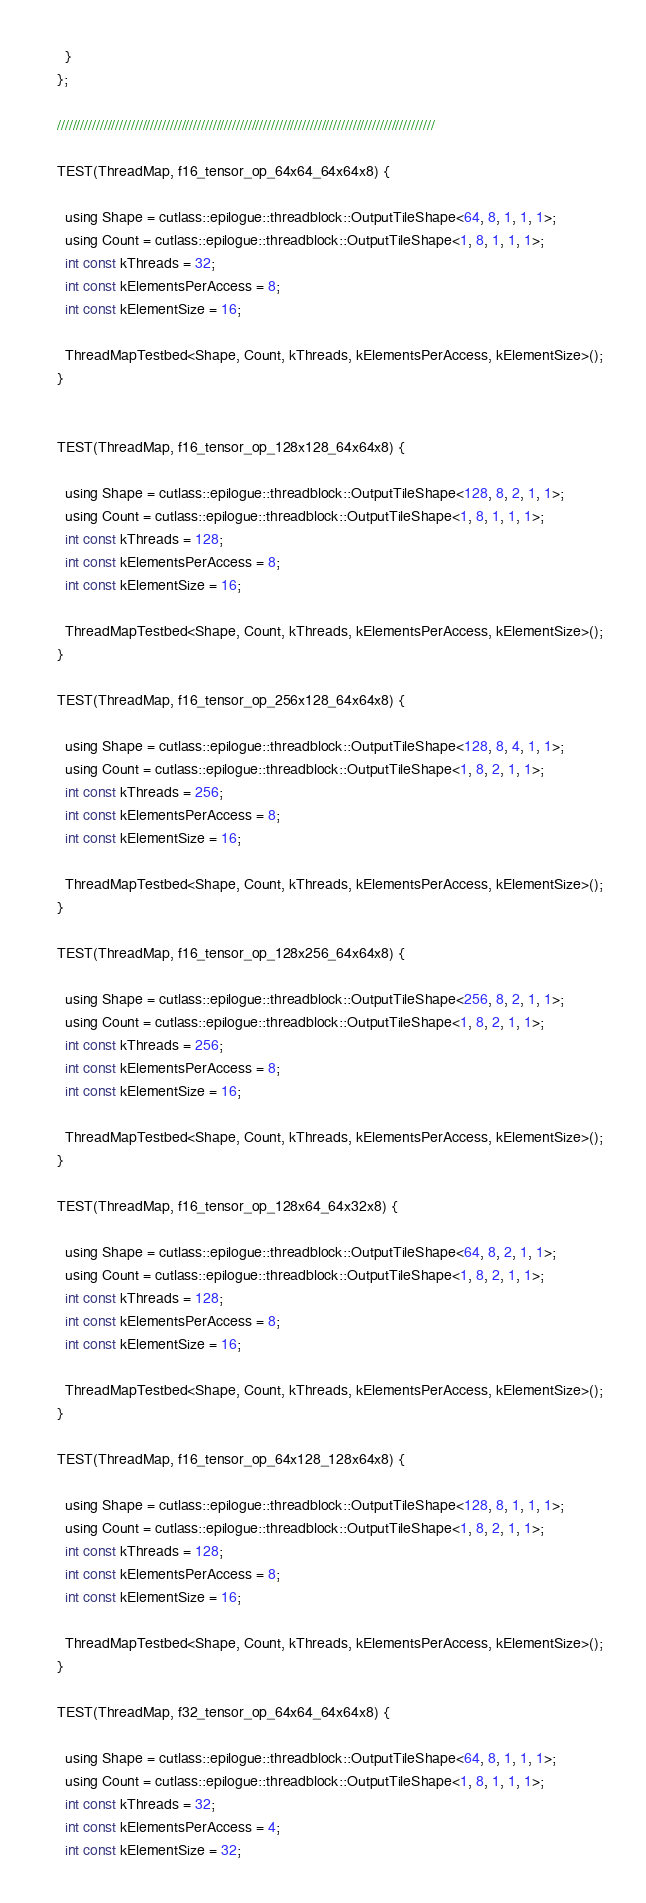<code> <loc_0><loc_0><loc_500><loc_500><_Cuda_>  }
};

/////////////////////////////////////////////////////////////////////////////////////////////////

TEST(ThreadMap, f16_tensor_op_64x64_64x64x8) {

  using Shape = cutlass::epilogue::threadblock::OutputTileShape<64, 8, 1, 1, 1>;
  using Count = cutlass::epilogue::threadblock::OutputTileShape<1, 8, 1, 1, 1>;
  int const kThreads = 32;
  int const kElementsPerAccess = 8;
  int const kElementSize = 16;

  ThreadMapTestbed<Shape, Count, kThreads, kElementsPerAccess, kElementSize>();
}


TEST(ThreadMap, f16_tensor_op_128x128_64x64x8) {

  using Shape = cutlass::epilogue::threadblock::OutputTileShape<128, 8, 2, 1, 1>;
  using Count = cutlass::epilogue::threadblock::OutputTileShape<1, 8, 1, 1, 1>;
  int const kThreads = 128;
  int const kElementsPerAccess = 8;
  int const kElementSize = 16;

  ThreadMapTestbed<Shape, Count, kThreads, kElementsPerAccess, kElementSize>();
}

TEST(ThreadMap, f16_tensor_op_256x128_64x64x8) {

  using Shape = cutlass::epilogue::threadblock::OutputTileShape<128, 8, 4, 1, 1>;
  using Count = cutlass::epilogue::threadblock::OutputTileShape<1, 8, 2, 1, 1>;
  int const kThreads = 256;
  int const kElementsPerAccess = 8;
  int const kElementSize = 16;

  ThreadMapTestbed<Shape, Count, kThreads, kElementsPerAccess, kElementSize>();
}

TEST(ThreadMap, f16_tensor_op_128x256_64x64x8) {

  using Shape = cutlass::epilogue::threadblock::OutputTileShape<256, 8, 2, 1, 1>;
  using Count = cutlass::epilogue::threadblock::OutputTileShape<1, 8, 2, 1, 1>;
  int const kThreads = 256;
  int const kElementsPerAccess = 8;
  int const kElementSize = 16;

  ThreadMapTestbed<Shape, Count, kThreads, kElementsPerAccess, kElementSize>();
}

TEST(ThreadMap, f16_tensor_op_128x64_64x32x8) {

  using Shape = cutlass::epilogue::threadblock::OutputTileShape<64, 8, 2, 1, 1>;
  using Count = cutlass::epilogue::threadblock::OutputTileShape<1, 8, 2, 1, 1>;
  int const kThreads = 128;
  int const kElementsPerAccess = 8;
  int const kElementSize = 16;

  ThreadMapTestbed<Shape, Count, kThreads, kElementsPerAccess, kElementSize>();
}

TEST(ThreadMap, f16_tensor_op_64x128_128x64x8) {

  using Shape = cutlass::epilogue::threadblock::OutputTileShape<128, 8, 1, 1, 1>;
  using Count = cutlass::epilogue::threadblock::OutputTileShape<1, 8, 2, 1, 1>;
  int const kThreads = 128;
  int const kElementsPerAccess = 8;
  int const kElementSize = 16;

  ThreadMapTestbed<Shape, Count, kThreads, kElementsPerAccess, kElementSize>();
}

TEST(ThreadMap, f32_tensor_op_64x64_64x64x8) {

  using Shape = cutlass::epilogue::threadblock::OutputTileShape<64, 8, 1, 1, 1>;
  using Count = cutlass::epilogue::threadblock::OutputTileShape<1, 8, 1, 1, 1>;
  int const kThreads = 32;
  int const kElementsPerAccess = 4;
  int const kElementSize = 32;
</code> 